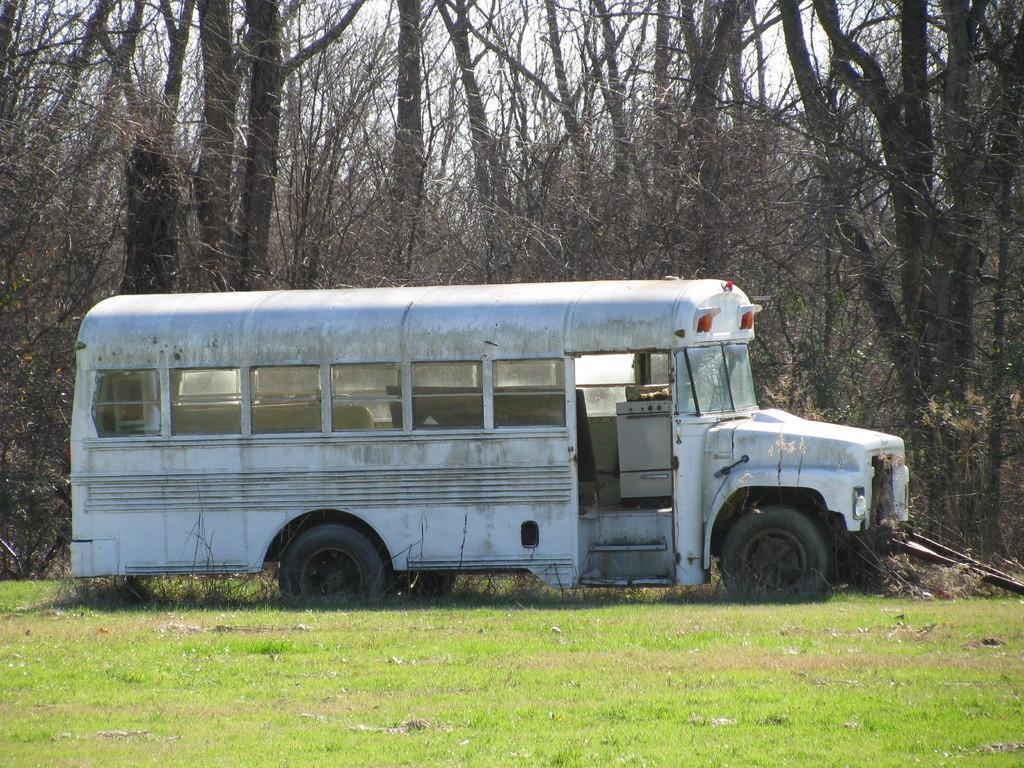Please provide a concise description of this image. In this image there is a vehicle on the surface of the grass. In the background there are trees and the sky. 